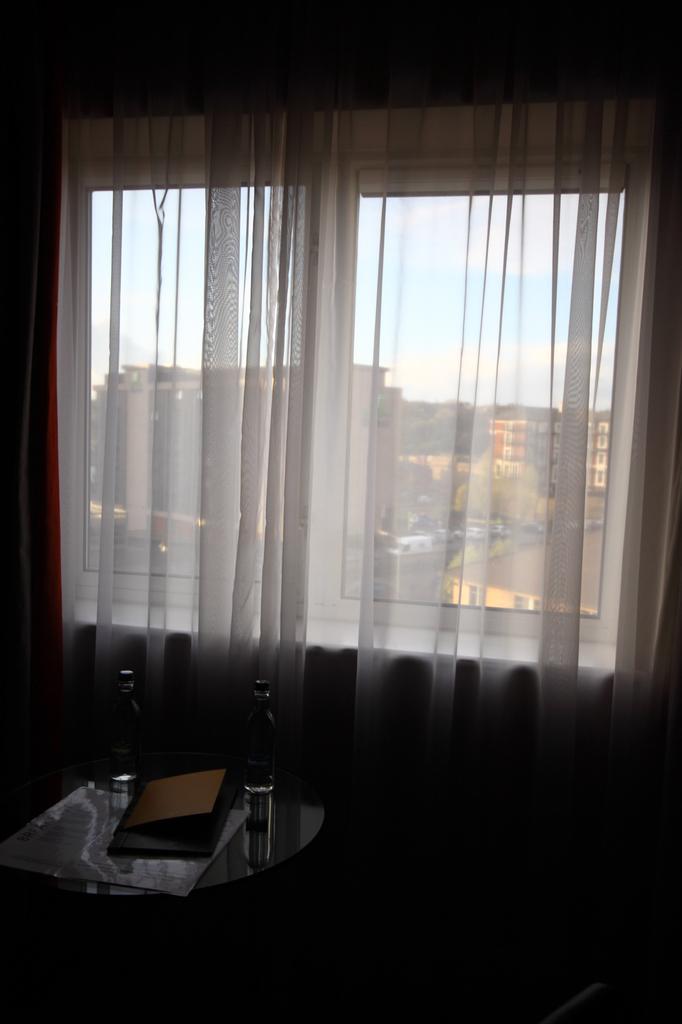Describe this image in one or two sentences. In this picture I can observe a table in the bottom of the picture. In the middle of the picture I can observe a window and curtain. In the background there are buildings and sky. 